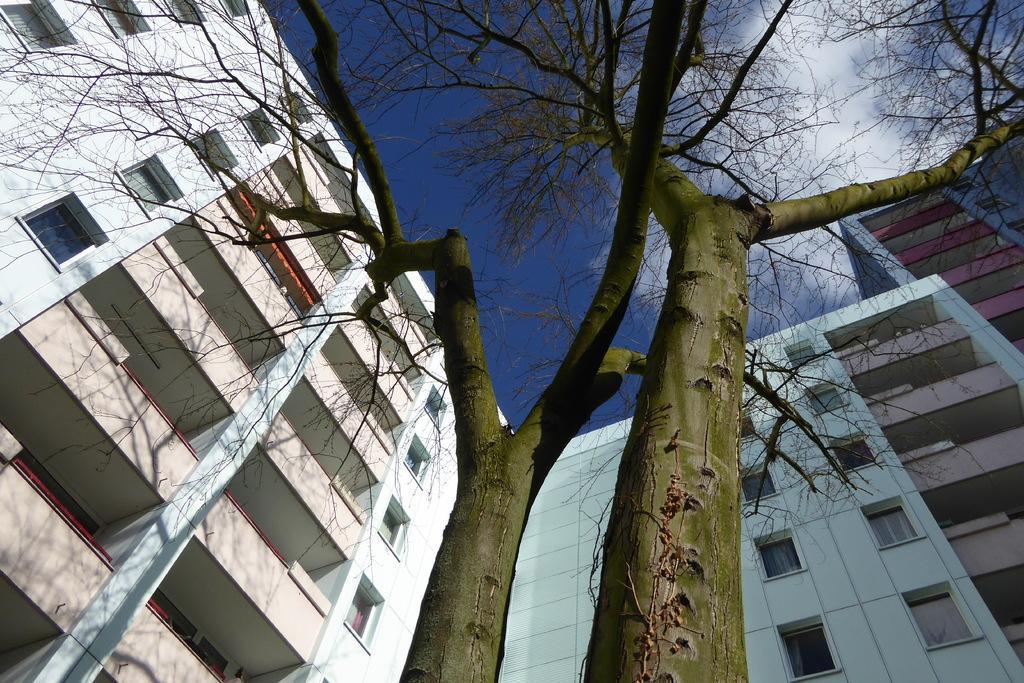Describe this image in one or two sentences. In this picture we can see few buildings, trees and clouds. 